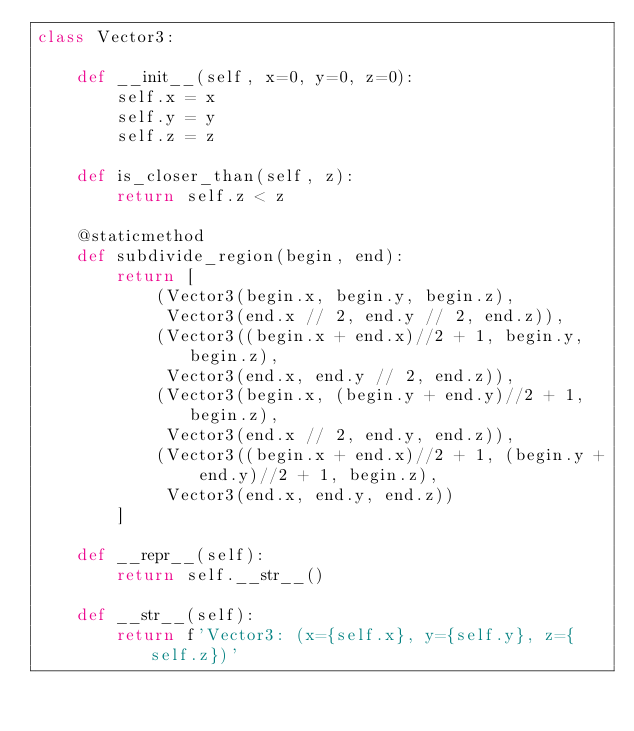Convert code to text. <code><loc_0><loc_0><loc_500><loc_500><_Python_>class Vector3:

    def __init__(self, x=0, y=0, z=0):
        self.x = x
        self.y = y
        self.z = z

    def is_closer_than(self, z):
        return self.z < z

    @staticmethod
    def subdivide_region(begin, end):
        return [
            (Vector3(begin.x, begin.y, begin.z),
             Vector3(end.x // 2, end.y // 2, end.z)),
            (Vector3((begin.x + end.x)//2 + 1, begin.y, begin.z),
             Vector3(end.x, end.y // 2, end.z)),
            (Vector3(begin.x, (begin.y + end.y)//2 + 1, begin.z),
             Vector3(end.x // 2, end.y, end.z)),
            (Vector3((begin.x + end.x)//2 + 1, (begin.y + end.y)//2 + 1, begin.z),
             Vector3(end.x, end.y, end.z))
        ]

    def __repr__(self):
        return self.__str__()

    def __str__(self):
        return f'Vector3: (x={self.x}, y={self.y}, z={self.z})'
</code> 